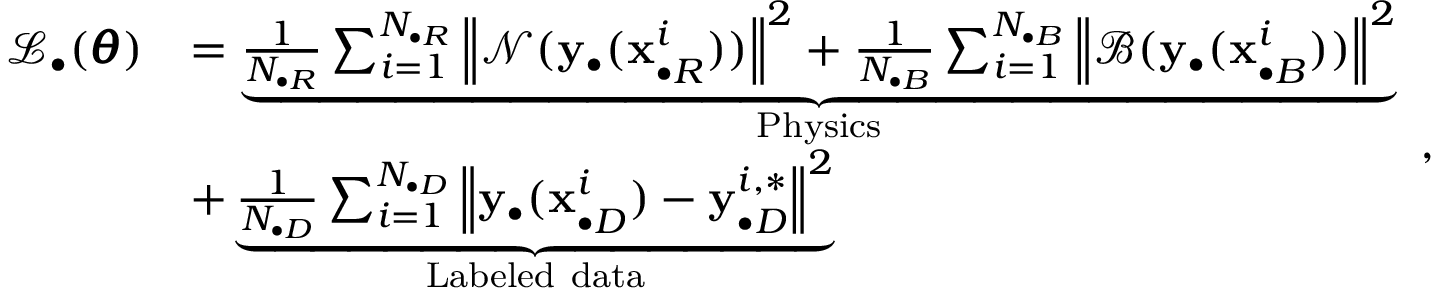<formula> <loc_0><loc_0><loc_500><loc_500>\begin{array} { r l } { \mathcal { L } _ { \bullet } ( \pm b { \theta } ) } & { = \underbrace { \frac { 1 } { N _ { \bullet R } } \sum _ { i = 1 } ^ { N _ { \bullet R } } { \left \| \mathcal { N } ( y _ { \bullet } ( x _ { \bullet R } ^ { i } ) ) \right \| ^ { 2 } } + \frac { 1 } { N _ { \bullet B } } \sum _ { i = 1 } ^ { N _ { \bullet B } } { \left \| \mathcal { B } ( y _ { \bullet } ( x _ { \bullet B } ^ { i } ) ) \right \| ^ { 2 } } } _ { P h y s i c s } } \\ & { + \underbrace { \frac { 1 } { N _ { \bullet D } } \sum _ { i = 1 } ^ { N _ { \bullet D } } { \left \| y _ { \bullet } ( x _ { \bullet D } ^ { i } ) - y _ { \bullet D } ^ { i , * } \right \| ^ { 2 } } } _ { L a b e l e d d a t a } } \end{array} ,</formula> 